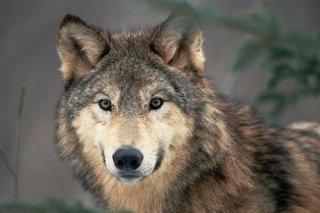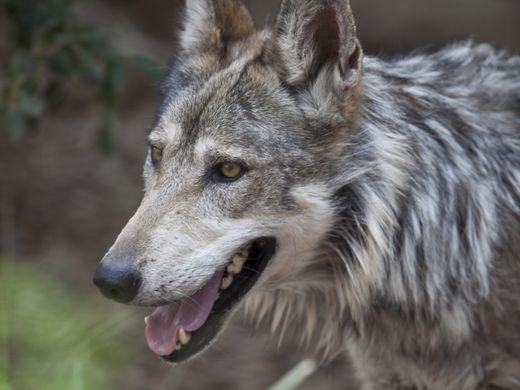The first image is the image on the left, the second image is the image on the right. Given the left and right images, does the statement "The wolf in the right image is facing towards the left." hold true? Answer yes or no. Yes. The first image is the image on the left, the second image is the image on the right. Examine the images to the left and right. Is the description "Each image contains exactly one wolf, and the righthand wolf faces leftward." accurate? Answer yes or no. Yes. 